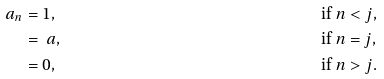Convert formula to latex. <formula><loc_0><loc_0><loc_500><loc_500>\ a _ { n } & = 1 , \quad & & \text {if } n < j , \\ & = \ a , \quad & & \text {if } n = j , \\ & = 0 , \quad & & \text {if } n > j .</formula> 